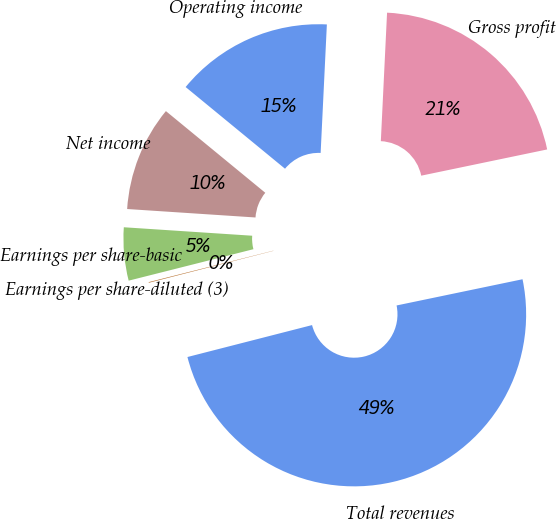Convert chart to OTSL. <chart><loc_0><loc_0><loc_500><loc_500><pie_chart><fcel>Total revenues<fcel>Gross profit<fcel>Operating income<fcel>Net income<fcel>Earnings per share-basic<fcel>Earnings per share-diluted (3)<nl><fcel>49.27%<fcel>20.96%<fcel>14.82%<fcel>9.9%<fcel>4.98%<fcel>0.06%<nl></chart> 